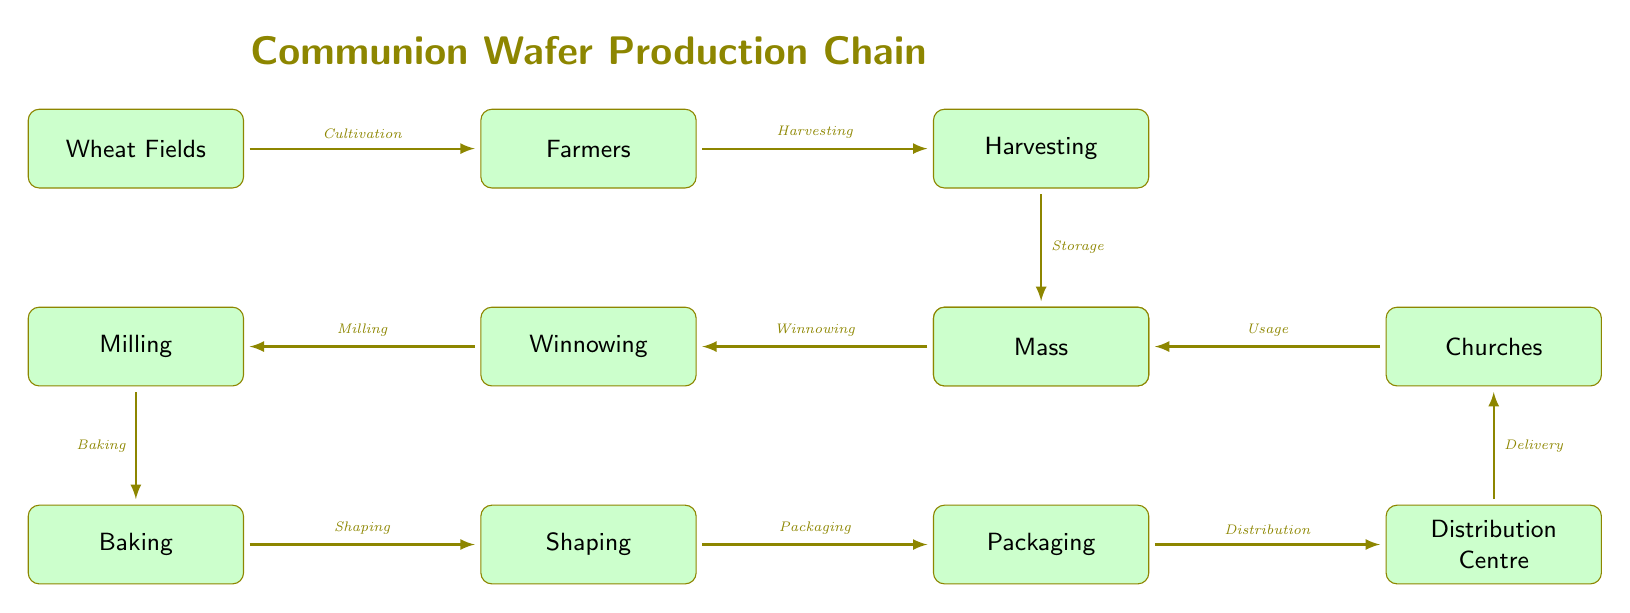What is the first step in the communion wafer production chain? The diagram shows "Wheat Fields" as the first node, indicating the initial step in the process of communion wafer production.
Answer: Wheat Fields How many steps are involved from "Wheat Fields" to "Mass"? Counting the arrows leading from "Wheat Fields" to "Mass" includes all nodes from cultivation to usage, resulting in a total of 10 steps.
Answer: 10 What is the last step in the food chain? The final node in the diagram is labeled "Mass," which represents the last step where the communion wafers are used.
Answer: Mass Which activity occurs after "Baking"? The next node that follows "Baking" according to the flow of the diagram is "Shaping," signifying the subsequent activity in the chain.
Answer: Shaping What is the role of "Distribution Centre"? The "Distribution Centre" node is responsible for the delivery of the finished products to their final destination, which is indicated by the arrow leading to "Churches."
Answer: Delivery What are the processes that contribute to the storage of the grain? The diagram shows "Grain Storage" following "Harvesting," implying that before the winnowing process, the harvested grain is stored.
Answer: Storage Which node is positioned below "Winnowing"? The diagram clearly indicates that "Milling" is positioned directly below "Winnowing," reflecting the sequential nature of these processes.
Answer: Milling What is the connection between "Packaging" and "Distribution Centre"? The arrow from "Packaging" to "Distribution Centre" illustrates that "Packaging" is a precursor to distribution, highlighting the role of packaging in preparing the product for delivery.
Answer: Distribution How does "Milling" relate to "Baking"? "Milling" directly leads into "Baking," indicating that milling the grain is essential before any baking process takes place in wafer production.
Answer: Baking 